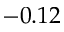<formula> <loc_0><loc_0><loc_500><loc_500>- 0 . 1 2</formula> 